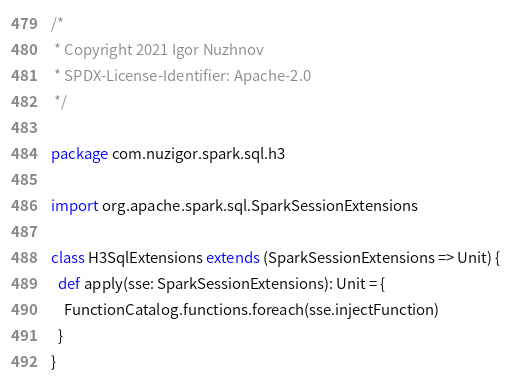Convert code to text. <code><loc_0><loc_0><loc_500><loc_500><_Scala_>/*
 * Copyright 2021 Igor Nuzhnov
 * SPDX-License-Identifier: Apache-2.0
 */

package com.nuzigor.spark.sql.h3

import org.apache.spark.sql.SparkSessionExtensions

class H3SqlExtensions extends (SparkSessionExtensions => Unit) {
  def apply(sse: SparkSessionExtensions): Unit = {
    FunctionCatalog.functions.foreach(sse.injectFunction)
  }
}
</code> 